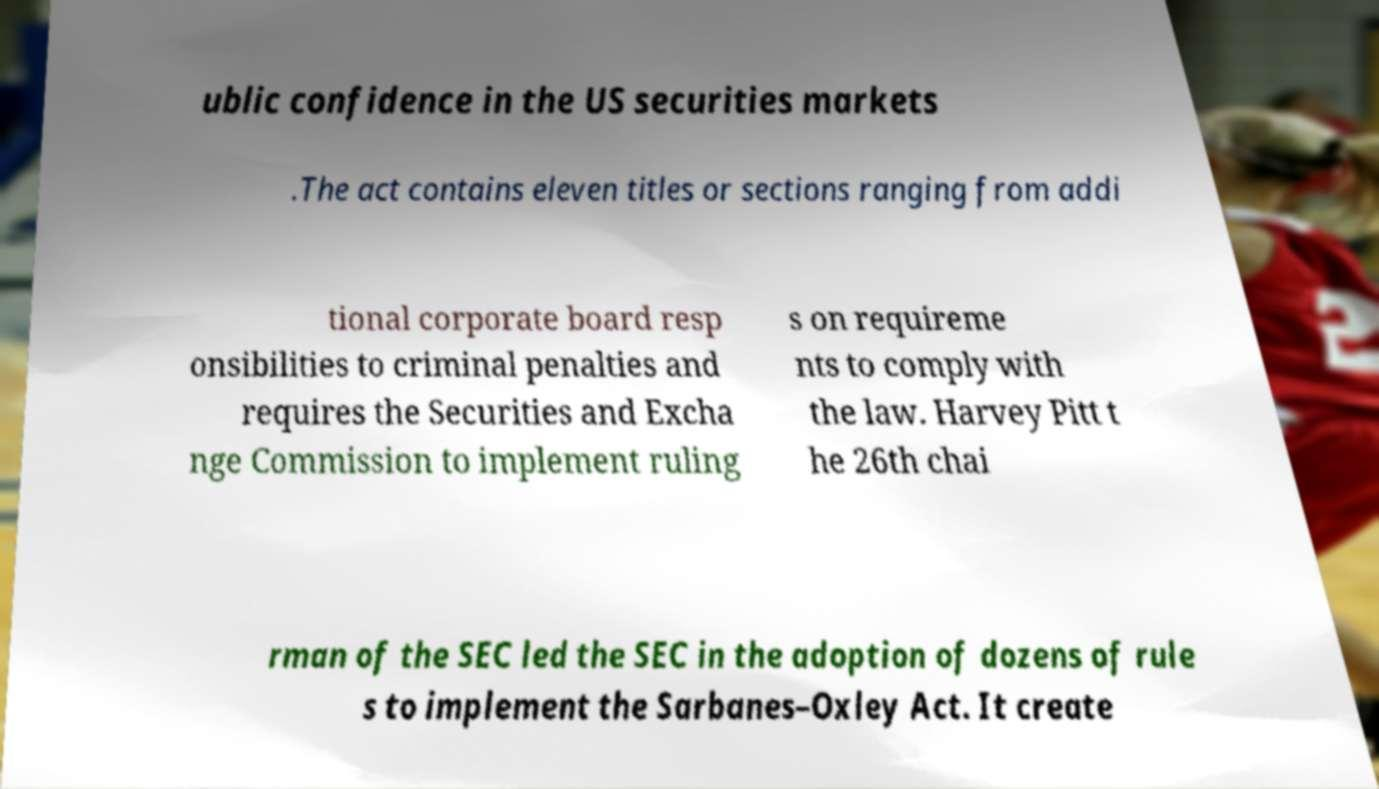Can you read and provide the text displayed in the image?This photo seems to have some interesting text. Can you extract and type it out for me? ublic confidence in the US securities markets .The act contains eleven titles or sections ranging from addi tional corporate board resp onsibilities to criminal penalties and requires the Securities and Excha nge Commission to implement ruling s on requireme nts to comply with the law. Harvey Pitt t he 26th chai rman of the SEC led the SEC in the adoption of dozens of rule s to implement the Sarbanes–Oxley Act. It create 